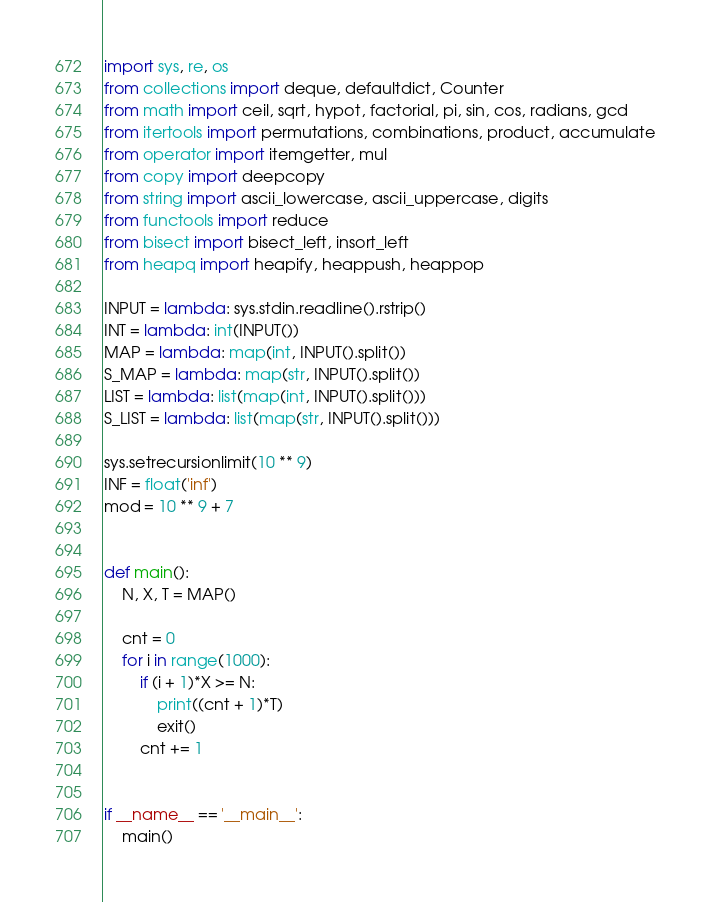<code> <loc_0><loc_0><loc_500><loc_500><_Python_>import sys, re, os
from collections import deque, defaultdict, Counter
from math import ceil, sqrt, hypot, factorial, pi, sin, cos, radians, gcd
from itertools import permutations, combinations, product, accumulate
from operator import itemgetter, mul
from copy import deepcopy
from string import ascii_lowercase, ascii_uppercase, digits
from functools import reduce
from bisect import bisect_left, insort_left
from heapq import heapify, heappush, heappop

INPUT = lambda: sys.stdin.readline().rstrip()
INT = lambda: int(INPUT())
MAP = lambda: map(int, INPUT().split())
S_MAP = lambda: map(str, INPUT().split())
LIST = lambda: list(map(int, INPUT().split()))
S_LIST = lambda: list(map(str, INPUT().split()))

sys.setrecursionlimit(10 ** 9)
INF = float('inf')
mod = 10 ** 9 + 7


def main():
    N, X, T = MAP()

    cnt = 0
    for i in range(1000):
        if (i + 1)*X >= N:
            print((cnt + 1)*T)
            exit()
        cnt += 1


if __name__ == '__main__':
    main()
</code> 